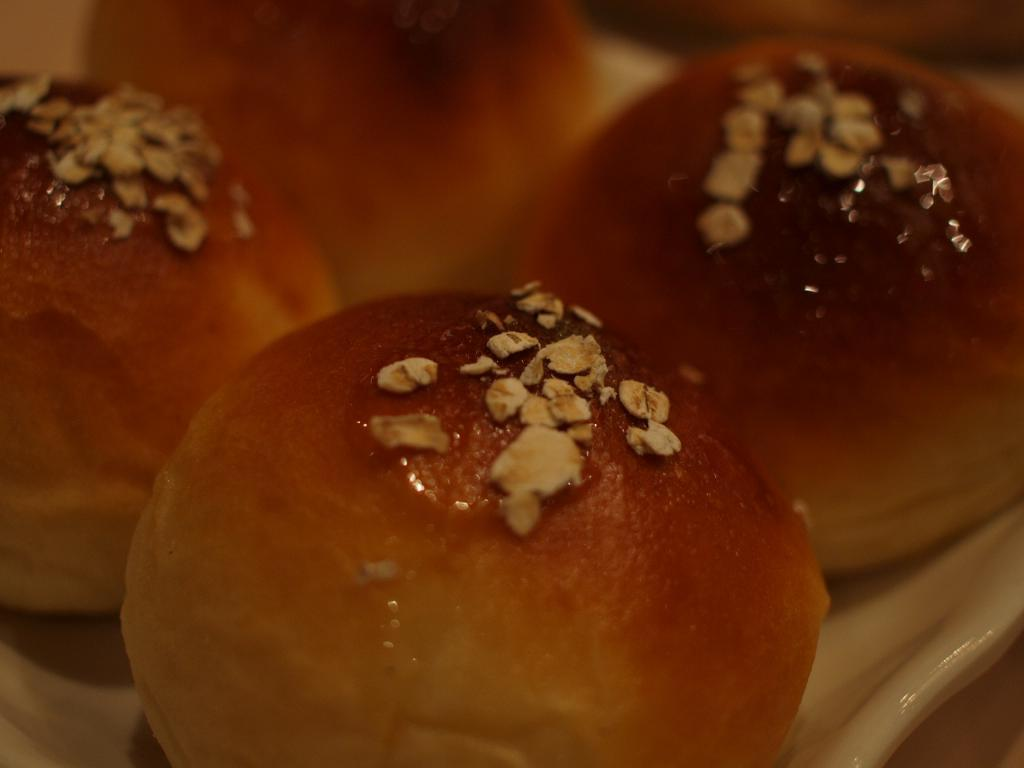What is placed in a tray in the image? There is food placed in a tray in the image. How are the food items decorated or topped? The food is topped with nuts. How many rabbits can be seen answering questions in the image? There are no rabbits or questions present in the image. 